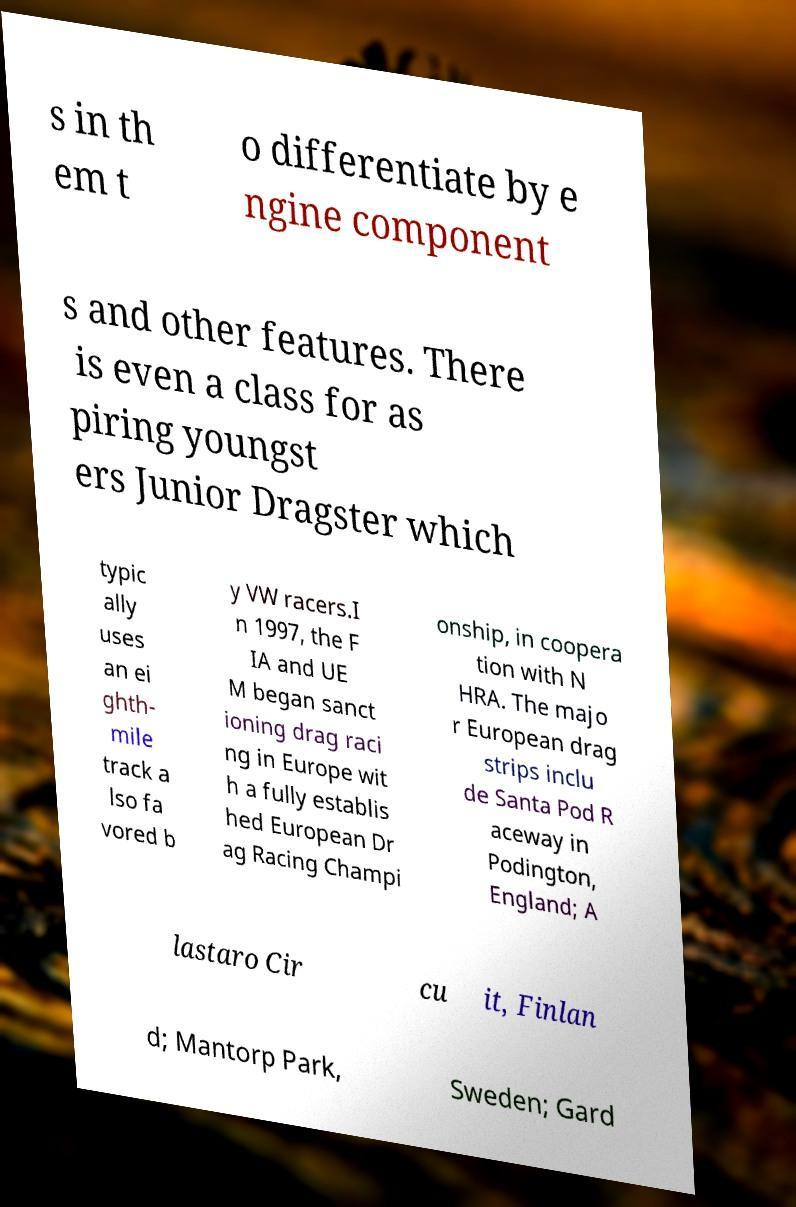Can you read and provide the text displayed in the image?This photo seems to have some interesting text. Can you extract and type it out for me? s in th em t o differentiate by e ngine component s and other features. There is even a class for as piring youngst ers Junior Dragster which typic ally uses an ei ghth- mile track a lso fa vored b y VW racers.I n 1997, the F IA and UE M began sanct ioning drag raci ng in Europe wit h a fully establis hed European Dr ag Racing Champi onship, in coopera tion with N HRA. The majo r European drag strips inclu de Santa Pod R aceway in Podington, England; A lastaro Cir cu it, Finlan d; Mantorp Park, Sweden; Gard 